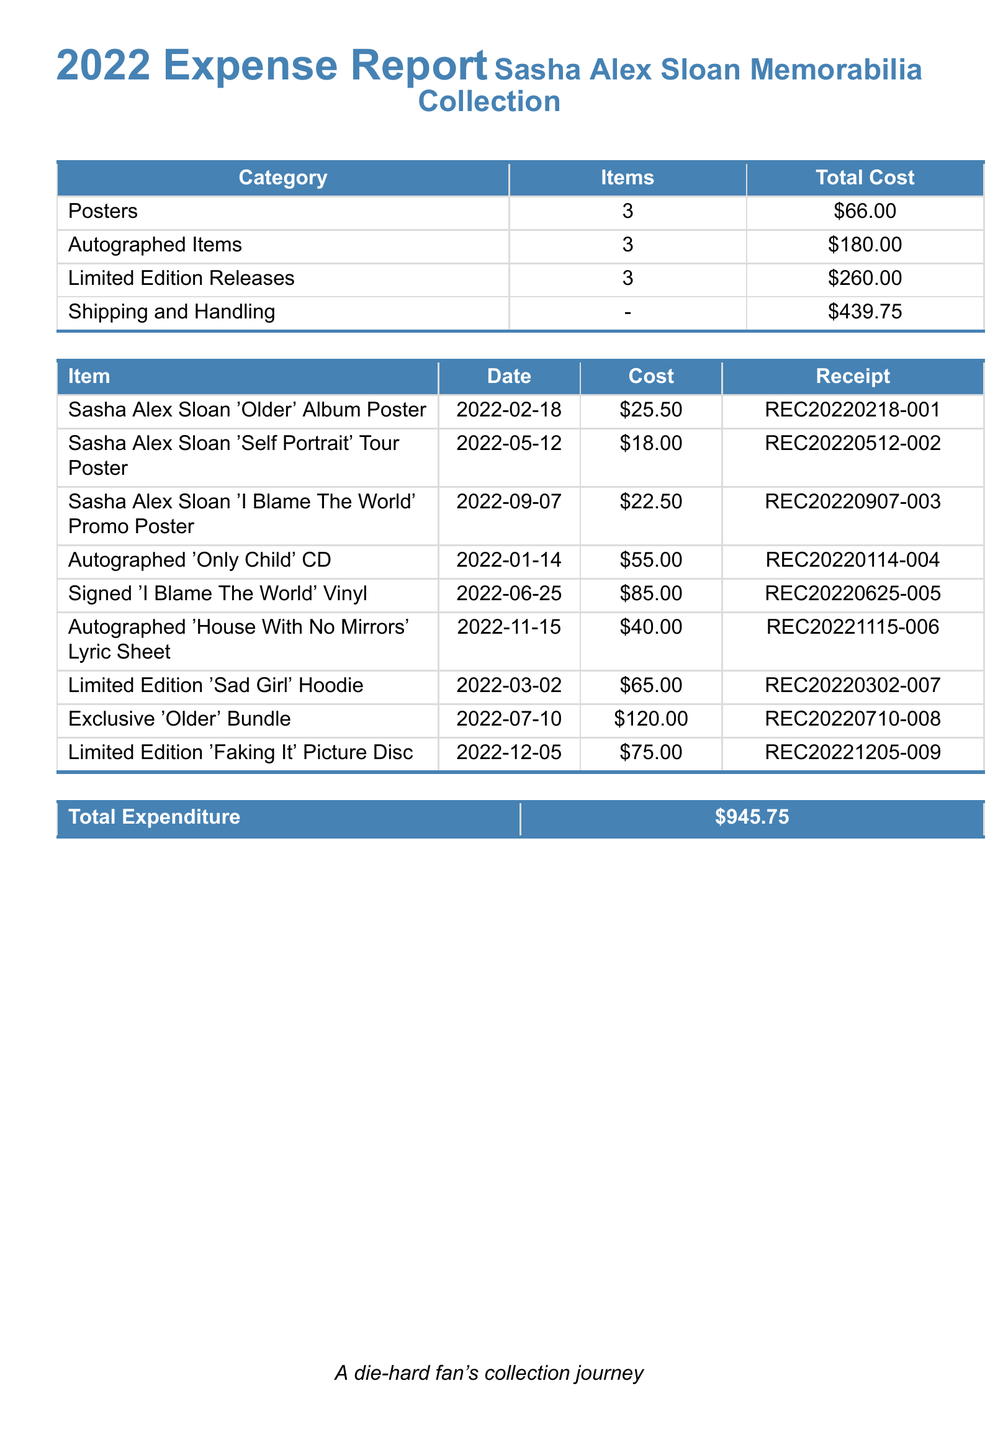What is the total expenditure? The total expenditure is listed at the bottom of the document, summarizing all costs associated with the memorabilia collection.
Answer: \$945.75 How many autographed items were purchased? The count of autographed items is displayed in the main table under the "Items" column for the category "Autographed Items."
Answer: 3 What was the cost of the signed 'I Blame The World' Vinyl? The specific cost is provided in the itemized list, directly reflecting the purchase price.
Answer: \$85.00 Which item was purchased on 2022-03-02? The date corresponds to an item listed in the table, giving details of the purchase made on that specific day.
Answer: Limited Edition 'Sad Girl' Hoodie How much was spent on shipping and handling? The total cost for shipping and handling is itemized in the main table, highlighting this specific expense.
Answer: \$439.75 What is the receipt number for the Sasha Alex Sloan 'Older' Album Poster? The receipt number is associated with the specific item listed in the document for tracking purposes.
Answer: REC20220218-001 What is the category with the highest total cost? The total costs for each category are compared in the main table to determine which one has the highest expense.
Answer: Shipping and Handling How many items were included in the Limited Edition Releases category? The number of items is noted in the main table under the "Items" column for that specific category.
Answer: 3 What was the cost of the Limited Edition 'Faking It' Picture Disc? The item cost is provided clearly in the table, along with its details including the purchase price.
Answer: \$75.00 